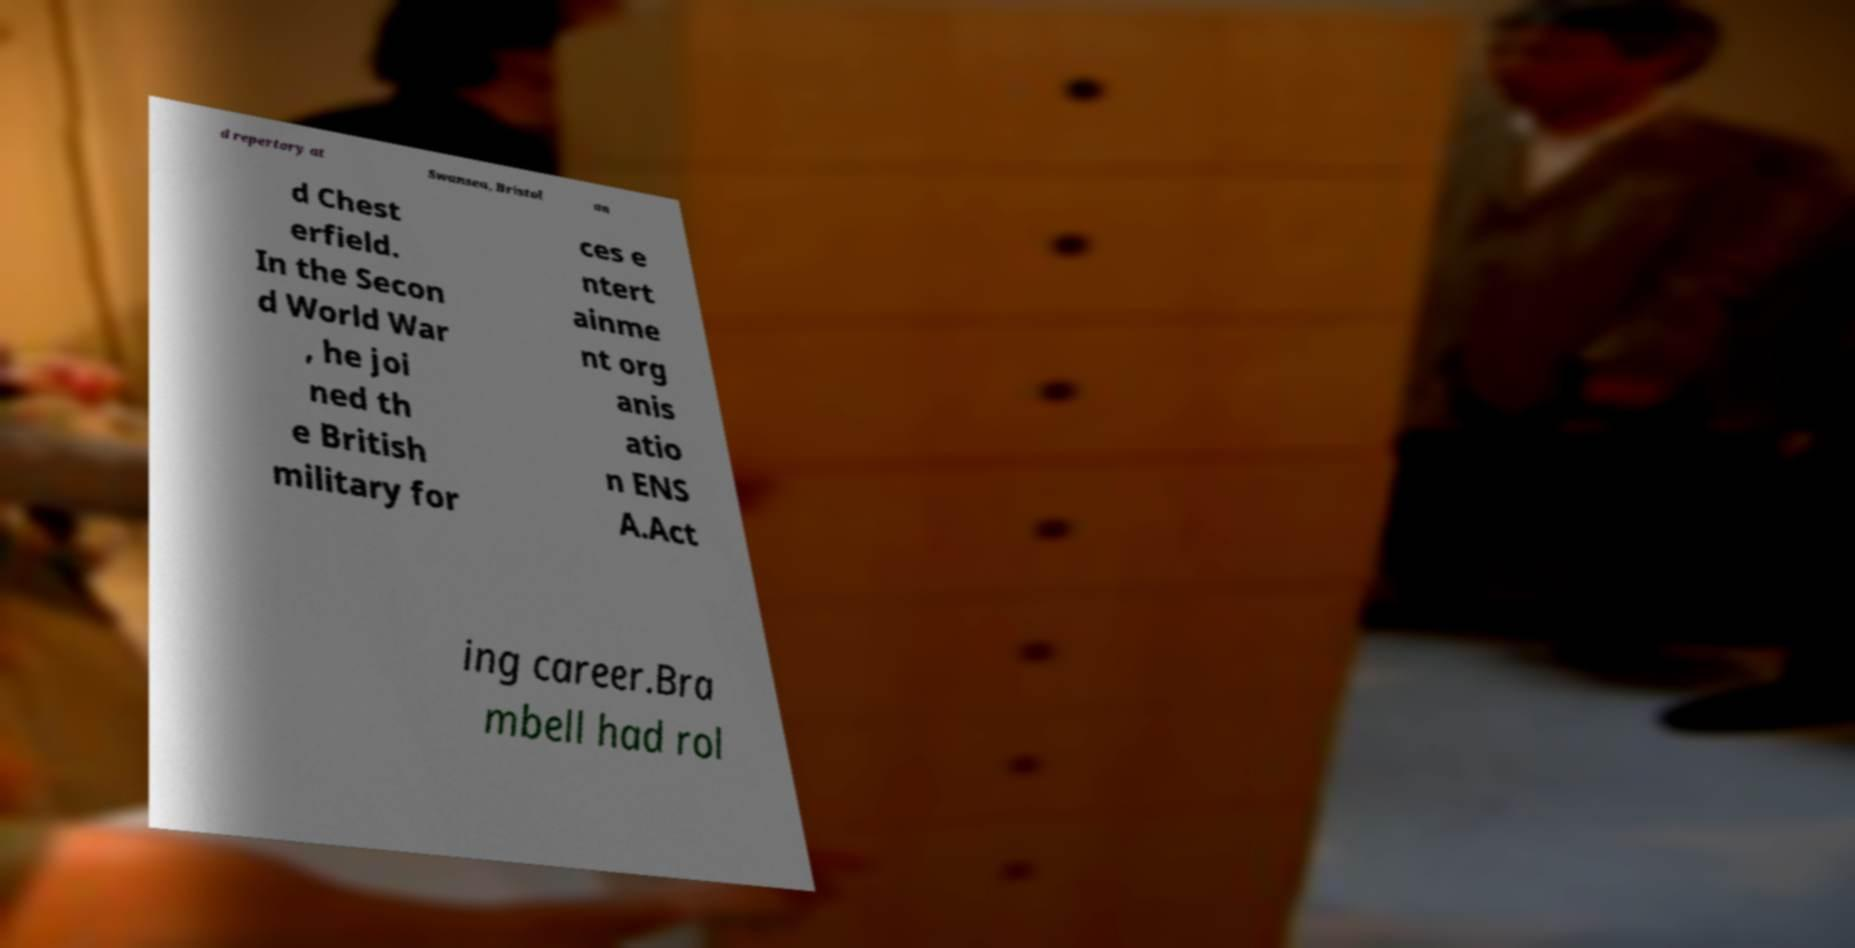Please read and relay the text visible in this image. What does it say? d repertory at Swansea, Bristol an d Chest erfield. In the Secon d World War , he joi ned th e British military for ces e ntert ainme nt org anis atio n ENS A.Act ing career.Bra mbell had rol 